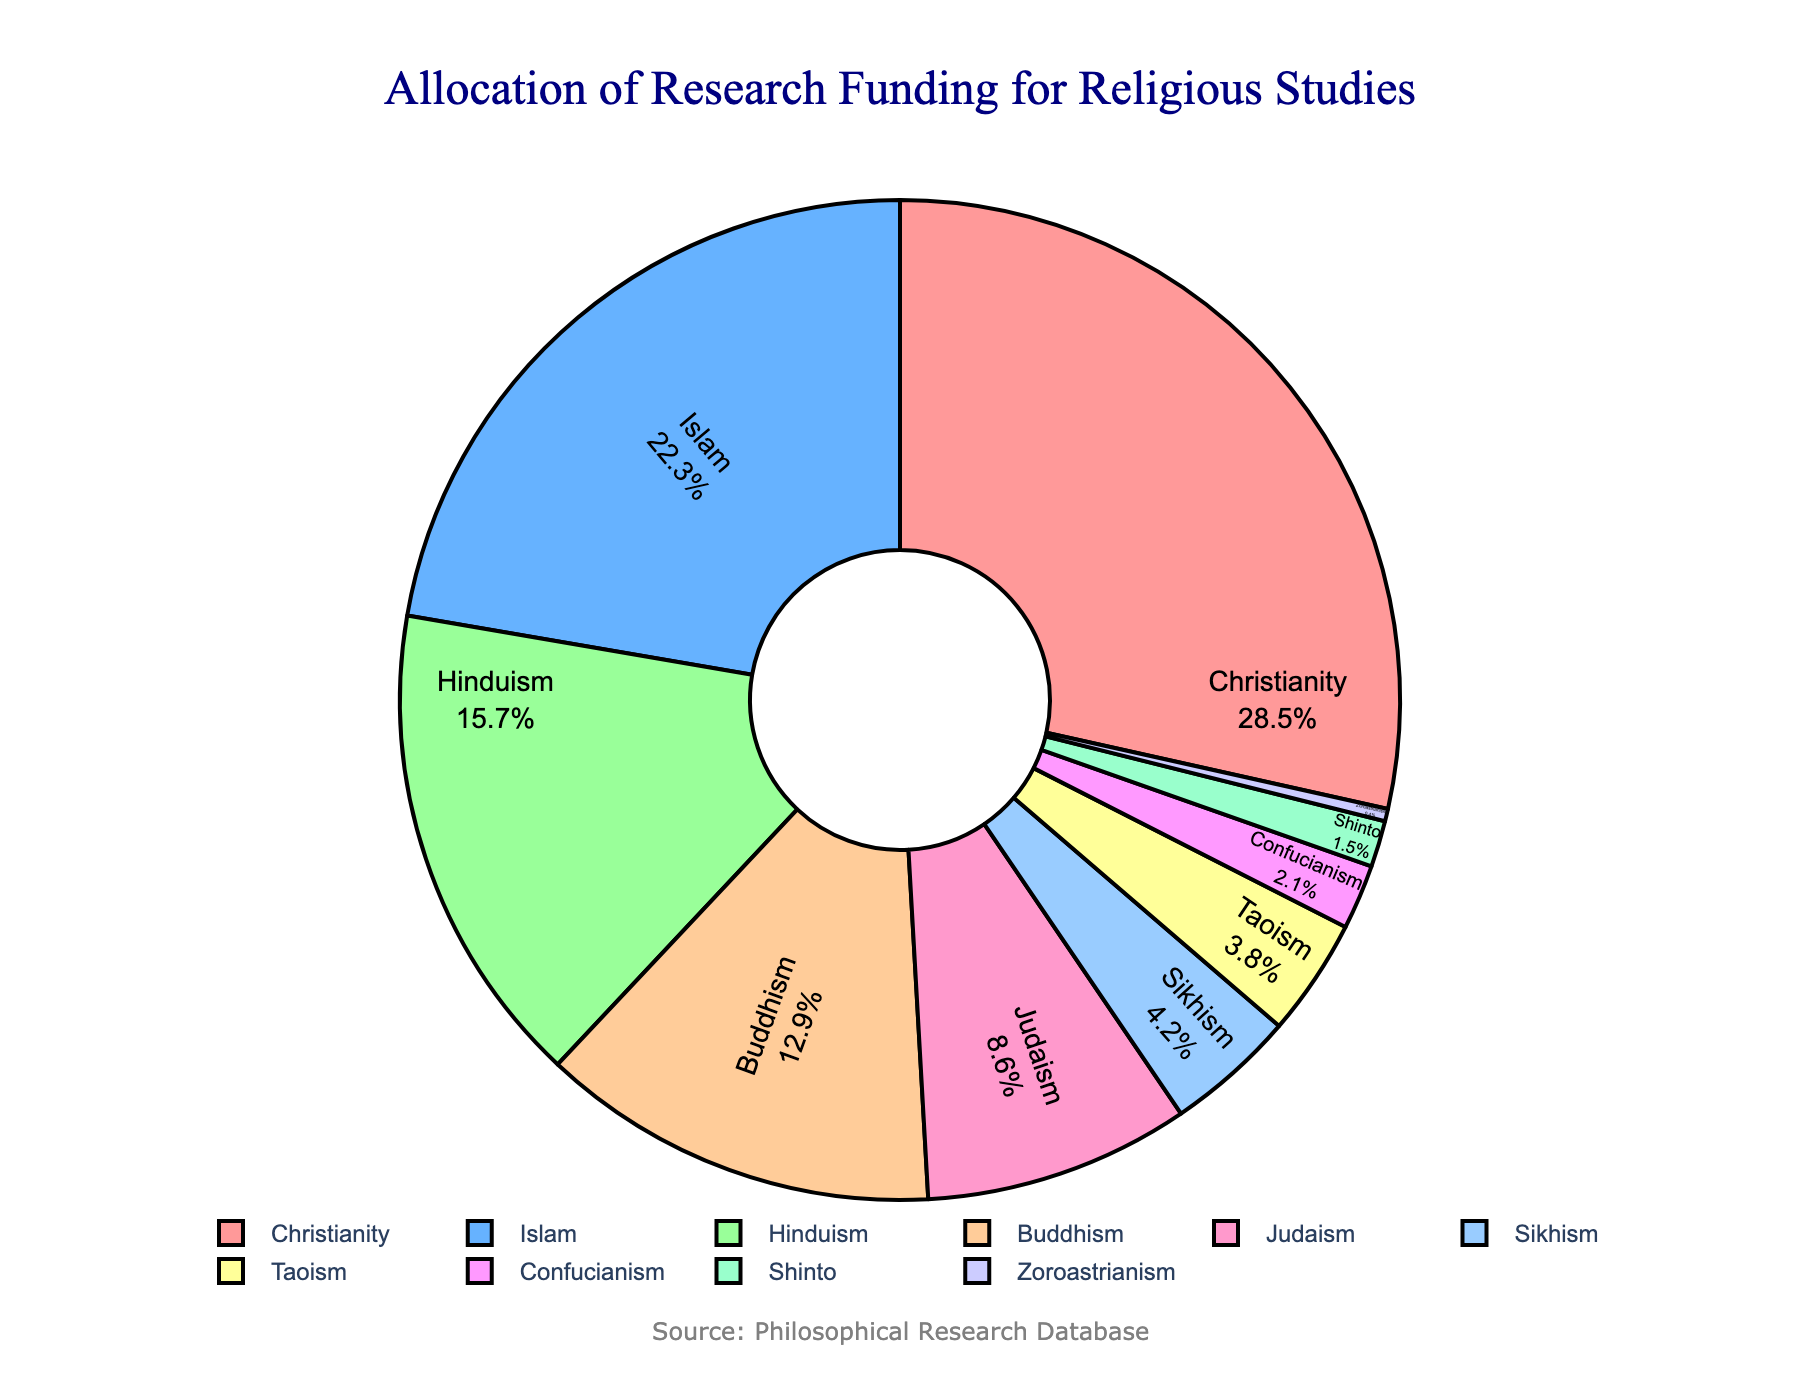What is the most significant portion of research funding allocated to? The largest segment of the pie chart represents Christianity, thus it receives the most significant portion of research funding.
Answer: Christianity Which faith receives the least amount of research funding? The smallest segment of the pie chart corresponds to Zoroastrianism, indicating it receives the least research funding.
Answer: Zoroastrianism Compare the funding percentages between Christianity and Islam. Which one is higher and by how much? The pie chart shows that Christianity has 28.5% and Islam has 22.3%. The difference is 28.5% - 22.3% = 6.2%. Thus, Christianity receives 6.2% more funding than Islam.
Answer: Christianity, 6.2% What is the combined funding percentage for Buddhism, Judaism, and Sikhism? Summing the percentages shown in the pie chart for Buddhism (12.9%), Judaism (8.6%), and Sikhism (4.2%) gives 12.9% + 8.6% + 4.2% = 25.7%.
Answer: 25.7% Examine the visual attributes: What color is assigned to Islam in the pie chart? The segment for Islam is represented by a blue color (second segment from the top).
Answer: Blue How does the funding for Hinduism compare to Buddhism? Hinduism is allocated 15.7% while Buddhism is allocated 12.9%. Hinduism receives a higher percentage of funding by 15.7% - 12.9% = 2.8%.
Answer: Hinduism, 2.8% Among the faiths receiving less than 5% funding, which one has the highest allocation? From the pie chart, the faiths receiving less than 5% funding are Sikhism, Taoism, Confucianism, Shinto, and Zoroastrianism. Sikhism has the highest percentage at 4.2%.
Answer: Sikhism What is the aggregate funding percentage for faiths allocated less than 3%? Summing up the percentages for Confucianism (2.1%), Shinto (1.5%), and Zoroastrianism (0.4%) yields 2.1% + 1.5% + 0.4% = 4%.
Answer: 4% Identify the funding percentage allocated to Taoism and describe its visual prominence. The pie chart shows Taoism has a funding percentage of 3.8%. Visually, it is a smaller segment close to the bottom of the pie chart.
Answer: 3.8% 